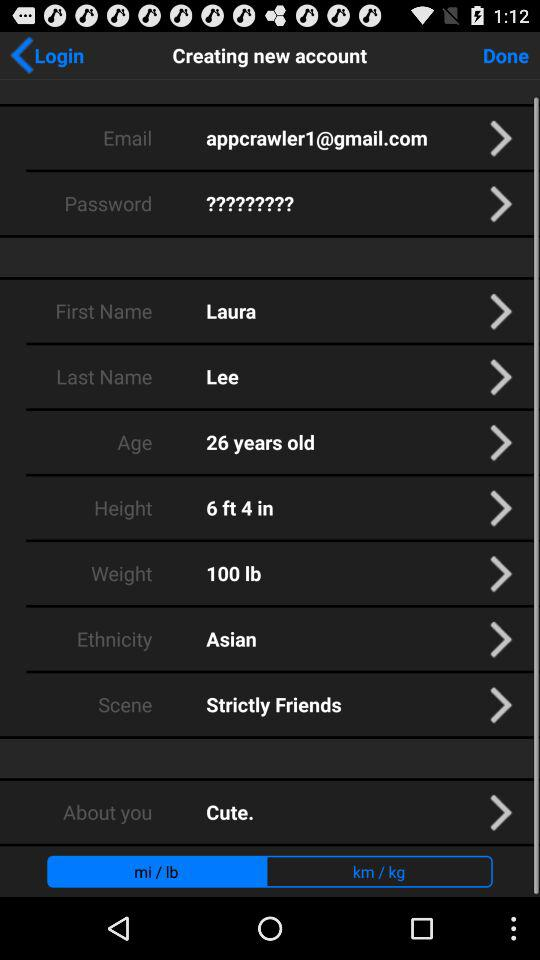How many characters are required to create a password?
When the provided information is insufficient, respond with <no answer>. <no answer> 